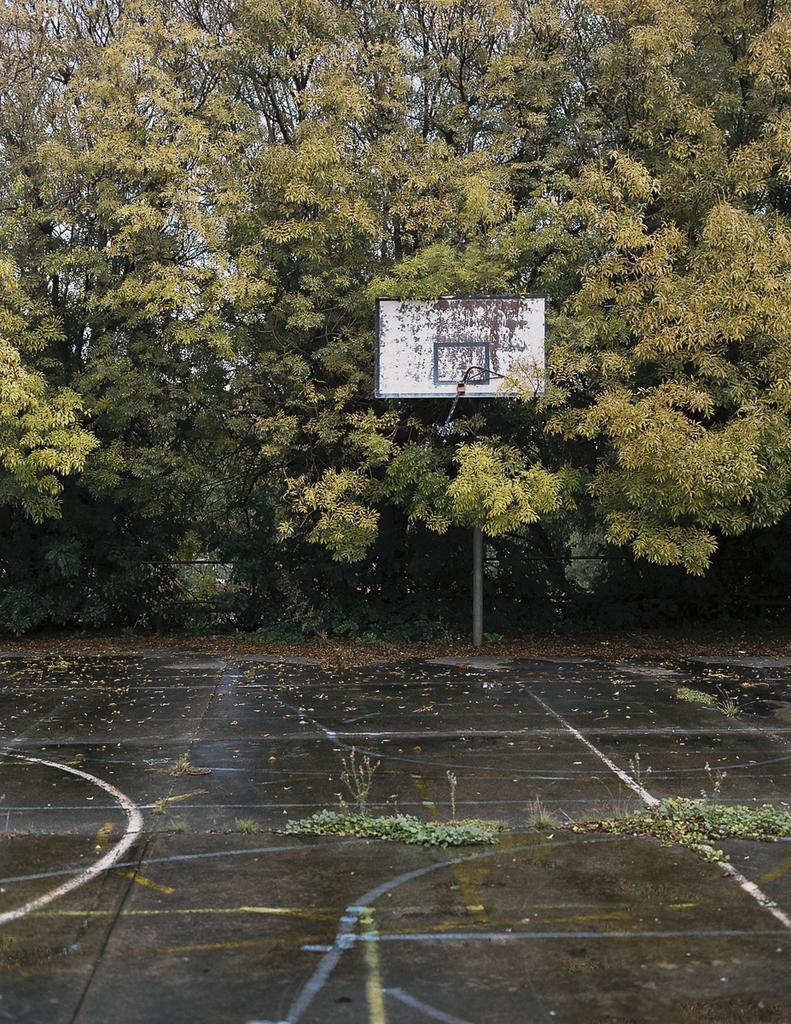Describe this image in one or two sentences. In this image we can see a goal post. We can also see some plants on the ground, a group of trees and the sky. 